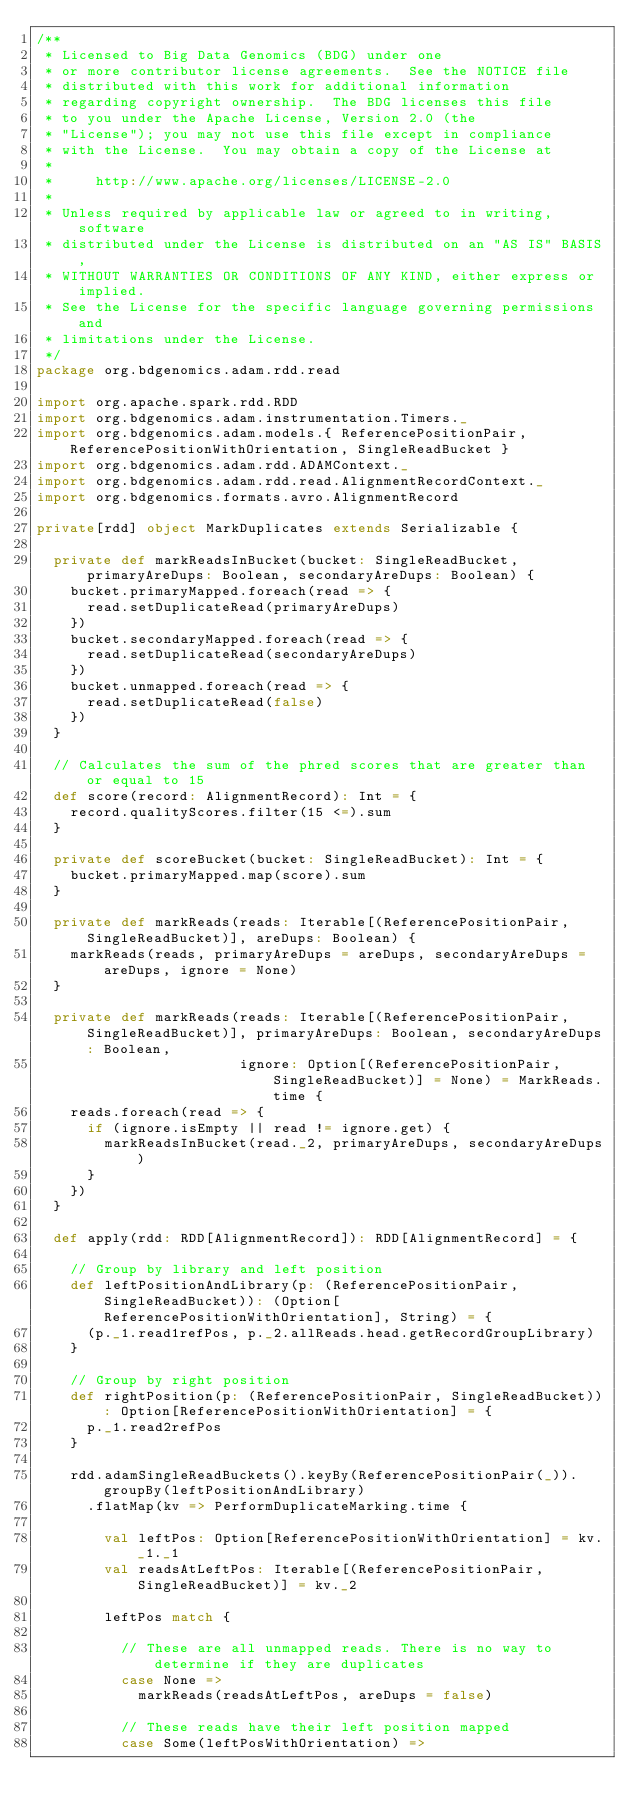Convert code to text. <code><loc_0><loc_0><loc_500><loc_500><_Scala_>/**
 * Licensed to Big Data Genomics (BDG) under one
 * or more contributor license agreements.  See the NOTICE file
 * distributed with this work for additional information
 * regarding copyright ownership.  The BDG licenses this file
 * to you under the Apache License, Version 2.0 (the
 * "License"); you may not use this file except in compliance
 * with the License.  You may obtain a copy of the License at
 *
 *     http://www.apache.org/licenses/LICENSE-2.0
 *
 * Unless required by applicable law or agreed to in writing, software
 * distributed under the License is distributed on an "AS IS" BASIS,
 * WITHOUT WARRANTIES OR CONDITIONS OF ANY KIND, either express or implied.
 * See the License for the specific language governing permissions and
 * limitations under the License.
 */
package org.bdgenomics.adam.rdd.read

import org.apache.spark.rdd.RDD
import org.bdgenomics.adam.instrumentation.Timers._
import org.bdgenomics.adam.models.{ ReferencePositionPair, ReferencePositionWithOrientation, SingleReadBucket }
import org.bdgenomics.adam.rdd.ADAMContext._
import org.bdgenomics.adam.rdd.read.AlignmentRecordContext._
import org.bdgenomics.formats.avro.AlignmentRecord

private[rdd] object MarkDuplicates extends Serializable {

  private def markReadsInBucket(bucket: SingleReadBucket, primaryAreDups: Boolean, secondaryAreDups: Boolean) {
    bucket.primaryMapped.foreach(read => {
      read.setDuplicateRead(primaryAreDups)
    })
    bucket.secondaryMapped.foreach(read => {
      read.setDuplicateRead(secondaryAreDups)
    })
    bucket.unmapped.foreach(read => {
      read.setDuplicateRead(false)
    })
  }

  // Calculates the sum of the phred scores that are greater than or equal to 15
  def score(record: AlignmentRecord): Int = {
    record.qualityScores.filter(15 <=).sum
  }

  private def scoreBucket(bucket: SingleReadBucket): Int = {
    bucket.primaryMapped.map(score).sum
  }

  private def markReads(reads: Iterable[(ReferencePositionPair, SingleReadBucket)], areDups: Boolean) {
    markReads(reads, primaryAreDups = areDups, secondaryAreDups = areDups, ignore = None)
  }

  private def markReads(reads: Iterable[(ReferencePositionPair, SingleReadBucket)], primaryAreDups: Boolean, secondaryAreDups: Boolean,
                        ignore: Option[(ReferencePositionPair, SingleReadBucket)] = None) = MarkReads.time {
    reads.foreach(read => {
      if (ignore.isEmpty || read != ignore.get) {
        markReadsInBucket(read._2, primaryAreDups, secondaryAreDups)
      }
    })
  }

  def apply(rdd: RDD[AlignmentRecord]): RDD[AlignmentRecord] = {

    // Group by library and left position
    def leftPositionAndLibrary(p: (ReferencePositionPair, SingleReadBucket)): (Option[ReferencePositionWithOrientation], String) = {
      (p._1.read1refPos, p._2.allReads.head.getRecordGroupLibrary)
    }

    // Group by right position
    def rightPosition(p: (ReferencePositionPair, SingleReadBucket)): Option[ReferencePositionWithOrientation] = {
      p._1.read2refPos
    }

    rdd.adamSingleReadBuckets().keyBy(ReferencePositionPair(_)).groupBy(leftPositionAndLibrary)
      .flatMap(kv => PerformDuplicateMarking.time {

        val leftPos: Option[ReferencePositionWithOrientation] = kv._1._1
        val readsAtLeftPos: Iterable[(ReferencePositionPair, SingleReadBucket)] = kv._2

        leftPos match {

          // These are all unmapped reads. There is no way to determine if they are duplicates
          case None =>
            markReads(readsAtLeftPos, areDups = false)

          // These reads have their left position mapped
          case Some(leftPosWithOrientation) =>
</code> 